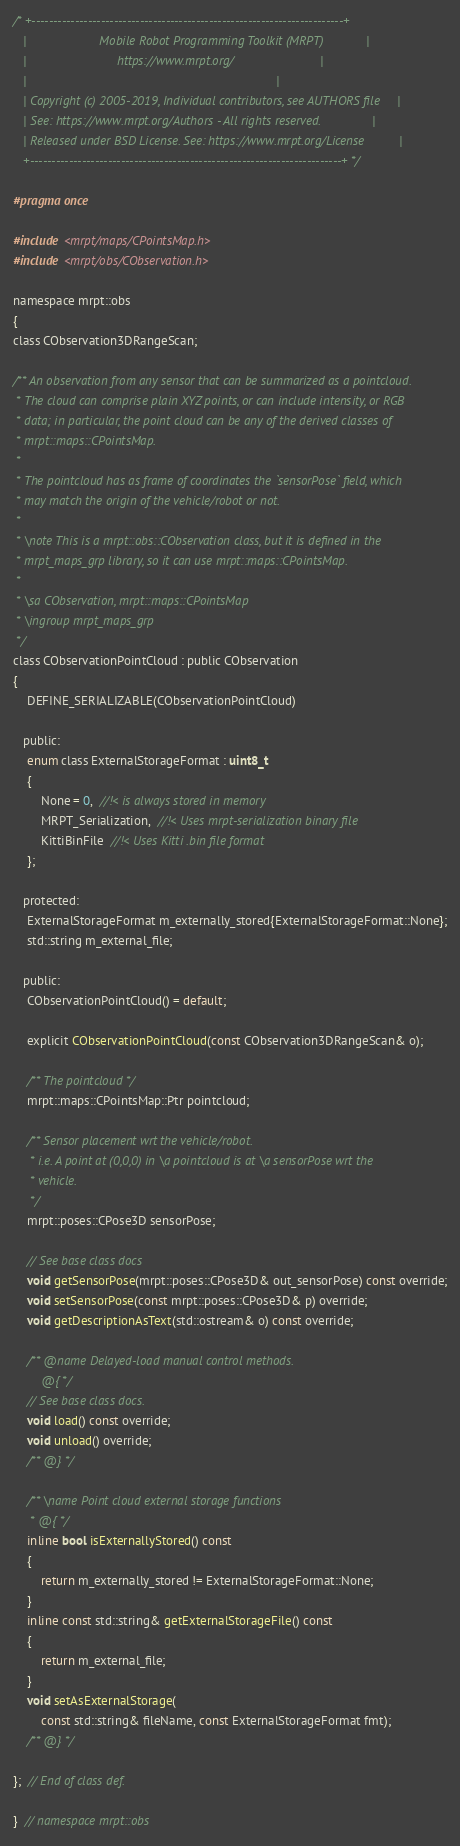<code> <loc_0><loc_0><loc_500><loc_500><_C_>/* +------------------------------------------------------------------------+
   |                     Mobile Robot Programming Toolkit (MRPT)            |
   |                          https://www.mrpt.org/                         |
   |                                                                        |
   | Copyright (c) 2005-2019, Individual contributors, see AUTHORS file     |
   | See: https://www.mrpt.org/Authors - All rights reserved.               |
   | Released under BSD License. See: https://www.mrpt.org/License          |
   +------------------------------------------------------------------------+ */

#pragma once

#include <mrpt/maps/CPointsMap.h>
#include <mrpt/obs/CObservation.h>

namespace mrpt::obs
{
class CObservation3DRangeScan;

/** An observation from any sensor that can be summarized as a pointcloud.
 * The cloud can comprise plain XYZ points, or can include intensity, or RGB
 * data; in particular, the point cloud can be any of the derived classes of
 * mrpt::maps::CPointsMap.
 *
 * The pointcloud has as frame of coordinates the `sensorPose` field, which
 * may match the origin of the vehicle/robot or not.
 *
 * \note This is a mrpt::obs::CObservation class, but it is defined in the
 * mrpt_maps_grp library, so it can use mrpt::maps::CPointsMap.
 *
 * \sa CObservation, mrpt::maps::CPointsMap
 * \ingroup mrpt_maps_grp
 */
class CObservationPointCloud : public CObservation
{
	DEFINE_SERIALIZABLE(CObservationPointCloud)

   public:
	enum class ExternalStorageFormat : uint8_t
	{
		None = 0,  //!< is always stored in memory
		MRPT_Serialization,  //!< Uses mrpt-serialization binary file
		KittiBinFile  //!< Uses Kitti .bin file format
	};

   protected:
	ExternalStorageFormat m_externally_stored{ExternalStorageFormat::None};
	std::string m_external_file;

   public:
	CObservationPointCloud() = default;

	explicit CObservationPointCloud(const CObservation3DRangeScan& o);

	/** The pointcloud */
	mrpt::maps::CPointsMap::Ptr pointcloud;

	/** Sensor placement wrt the vehicle/robot.
	 * i.e. A point at (0,0,0) in \a pointcloud is at \a sensorPose wrt the
	 * vehicle.
	 */
	mrpt::poses::CPose3D sensorPose;

	// See base class docs
	void getSensorPose(mrpt::poses::CPose3D& out_sensorPose) const override;
	void setSensorPose(const mrpt::poses::CPose3D& p) override;
	void getDescriptionAsText(std::ostream& o) const override;

	/** @name Delayed-load manual control methods.
		@{ */
	// See base class docs.
	void load() const override;
	void unload() override;
	/** @} */

	/** \name Point cloud external storage functions
	 * @{ */
	inline bool isExternallyStored() const
	{
		return m_externally_stored != ExternalStorageFormat::None;
	}
	inline const std::string& getExternalStorageFile() const
	{
		return m_external_file;
	}
	void setAsExternalStorage(
		const std::string& fileName, const ExternalStorageFormat fmt);
	/** @} */

};  // End of class def.

}  // namespace mrpt::obs
</code> 